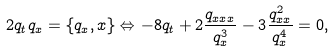<formula> <loc_0><loc_0><loc_500><loc_500>2 q _ { t } q _ { x } = \{ q _ { x } , x \} \Leftrightarrow - 8 q _ { t } + 2 \frac { q _ { x x x } } { q _ { x } ^ { 3 } } - 3 \frac { q _ { x x } ^ { 2 } } { q _ { x } ^ { 4 } } = 0 ,</formula> 